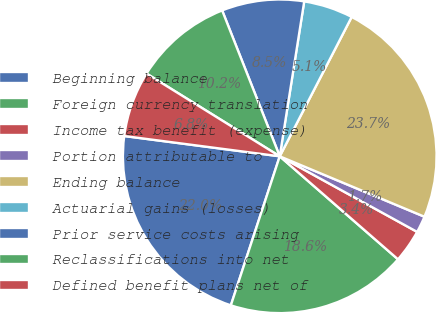Convert chart to OTSL. <chart><loc_0><loc_0><loc_500><loc_500><pie_chart><fcel>Beginning balance<fcel>Foreign currency translation<fcel>Income tax benefit (expense)<fcel>Portion attributable to<fcel>Ending balance<fcel>Actuarial gains (losses)<fcel>Prior service costs arising<fcel>Reclassifications into net<fcel>Defined benefit plans net of<nl><fcel>22.02%<fcel>18.64%<fcel>3.4%<fcel>1.71%<fcel>23.71%<fcel>5.09%<fcel>8.48%<fcel>10.17%<fcel>6.78%<nl></chart> 